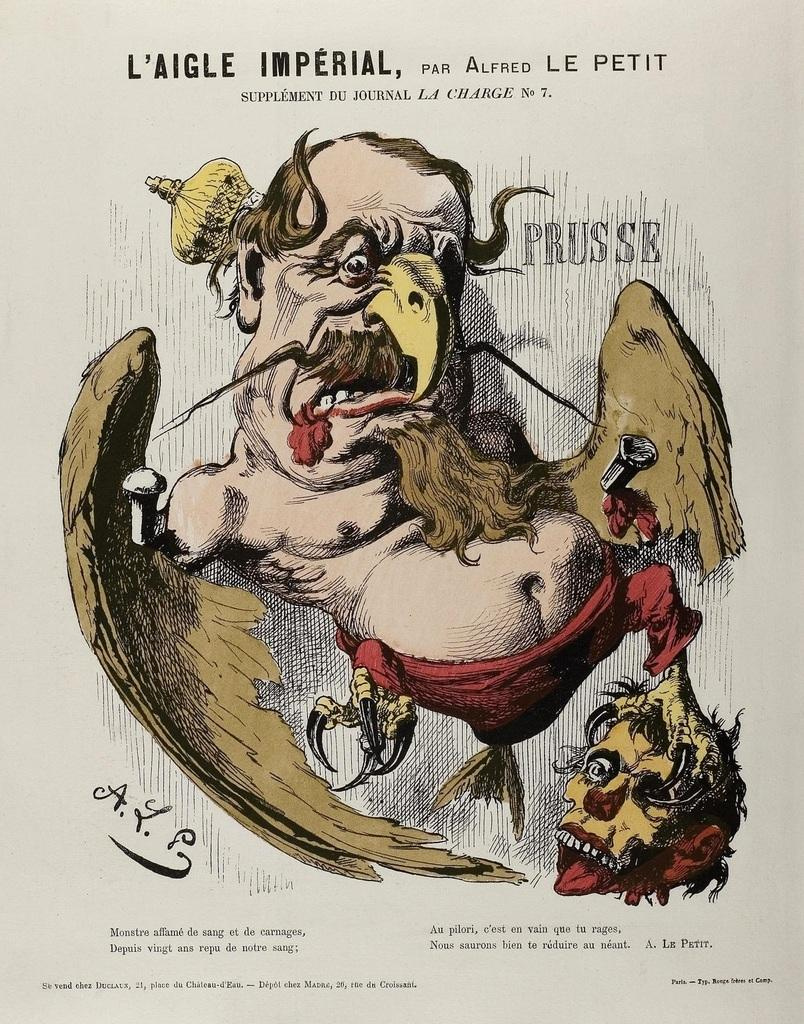What type of visual is the image in question? The image is a poster. What can be found on the poster besides the image of a person? There is text and objects present on the poster. Can you describe the person depicted on the poster? The head of a person is visible on the poster. What type of toothpaste is being advertised by the queen on the poster? There is no queen or toothpaste present on the poster; it features an image of a person and text. 